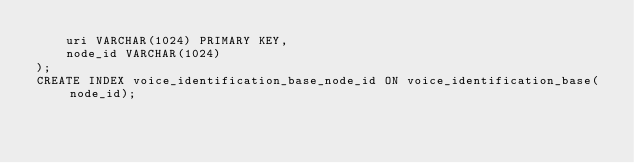Convert code to text. <code><loc_0><loc_0><loc_500><loc_500><_SQL_>    uri VARCHAR(1024) PRIMARY KEY,
    node_id VARCHAR(1024)
);
CREATE INDEX voice_identification_base_node_id ON voice_identification_base(node_id);</code> 